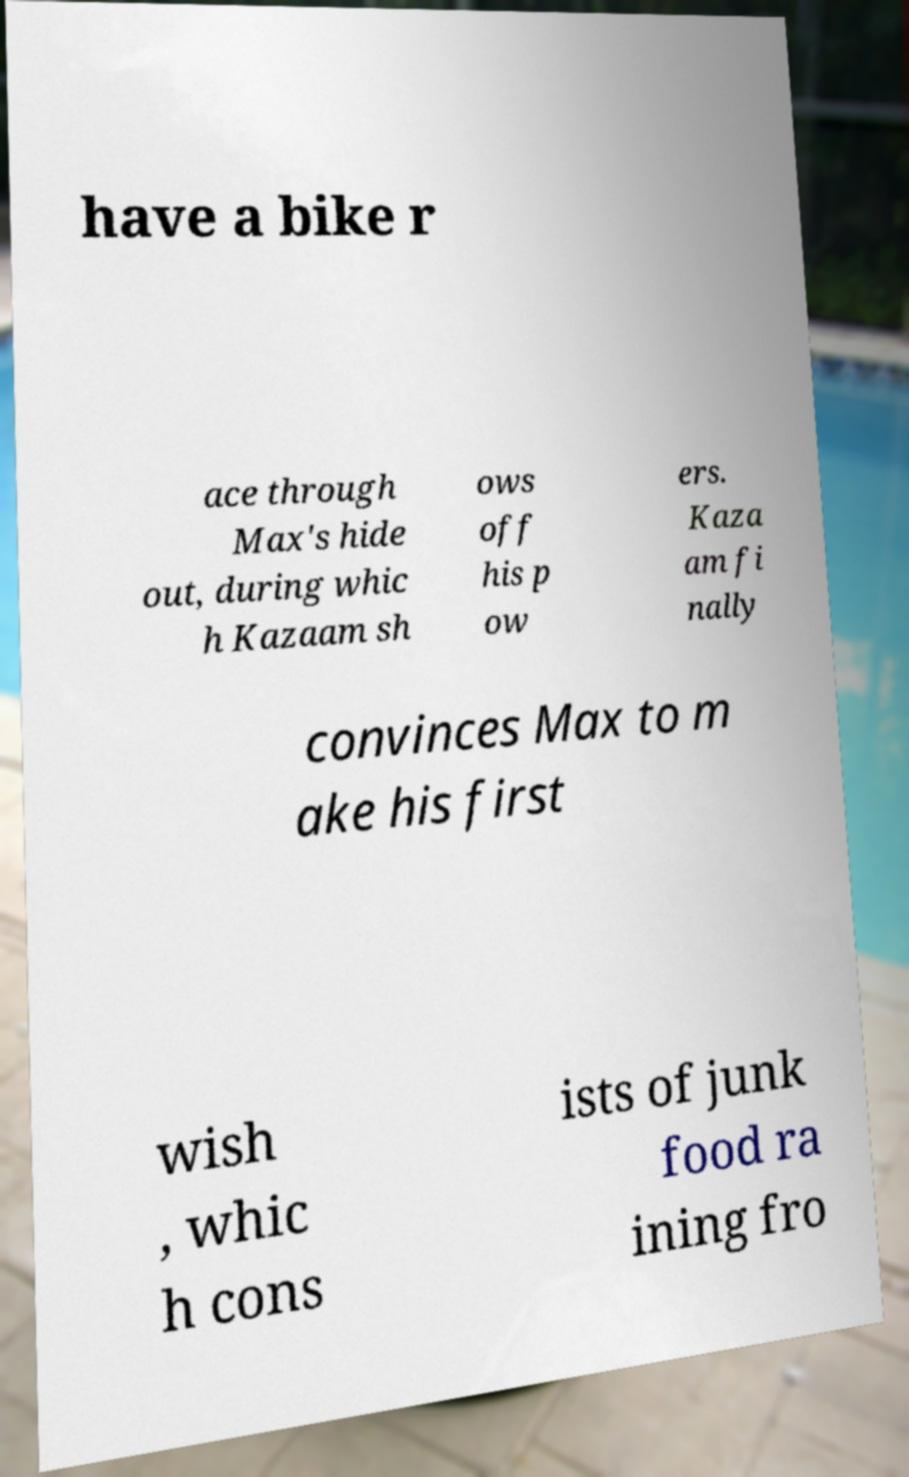Could you assist in decoding the text presented in this image and type it out clearly? have a bike r ace through Max's hide out, during whic h Kazaam sh ows off his p ow ers. Kaza am fi nally convinces Max to m ake his first wish , whic h cons ists of junk food ra ining fro 